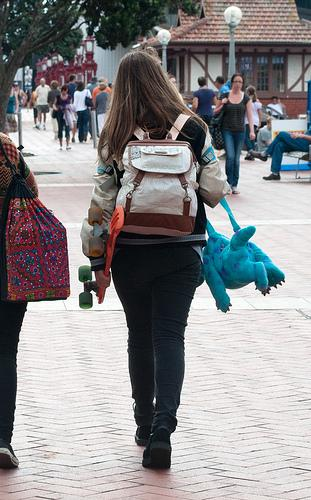Can you identify any footwear in the image? Yes, there is a girl wearing a pair of black shoes. What type of expression or emotion do you think this image portrays? The image portrays a casual and relaxed atmosphere in an urban setting. Are there any unique or unusual objects in the image? Yes, there is a blue monster bag and an orange skateboard with green wheels. What descriptors or adjectives can be used for the woman's clothing items in the image? She is wearing a brown and white jacket, black pants, and a beige backpack. List three objects that can be found in the image. An orange skateboard with green wheels, a blue monster bag, and a beige backpack. Provide a brief summary of the scene in this image. A young woman is walking down a street carrying a longboard and a backpack, with a blue monster bag hanging from her shoulder. Count the number of windows in the image. There are no visible windows in the image. Analyze the interactions between the woman and the objects around her. The woman is walking while carrying a longboard and a backpack, with a blue monster bag hanging from her shoulder, interacting casually with her urban surroundings. What is happening in regard to lighting in the image? The image is taken during daylight with natural lighting. What is the primary focus of the image? The primary focus of the image is the woman walking down the street carrying a longboard and a backpack. 